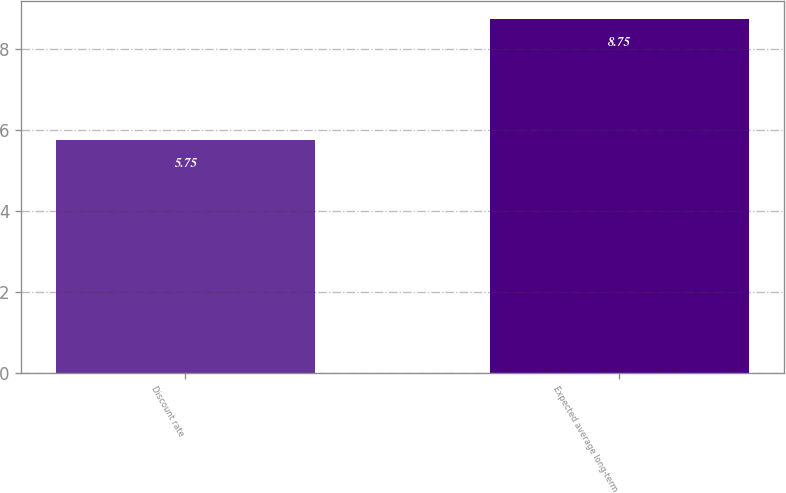<chart> <loc_0><loc_0><loc_500><loc_500><bar_chart><fcel>Discount rate<fcel>Expected average long-term<nl><fcel>5.75<fcel>8.75<nl></chart> 